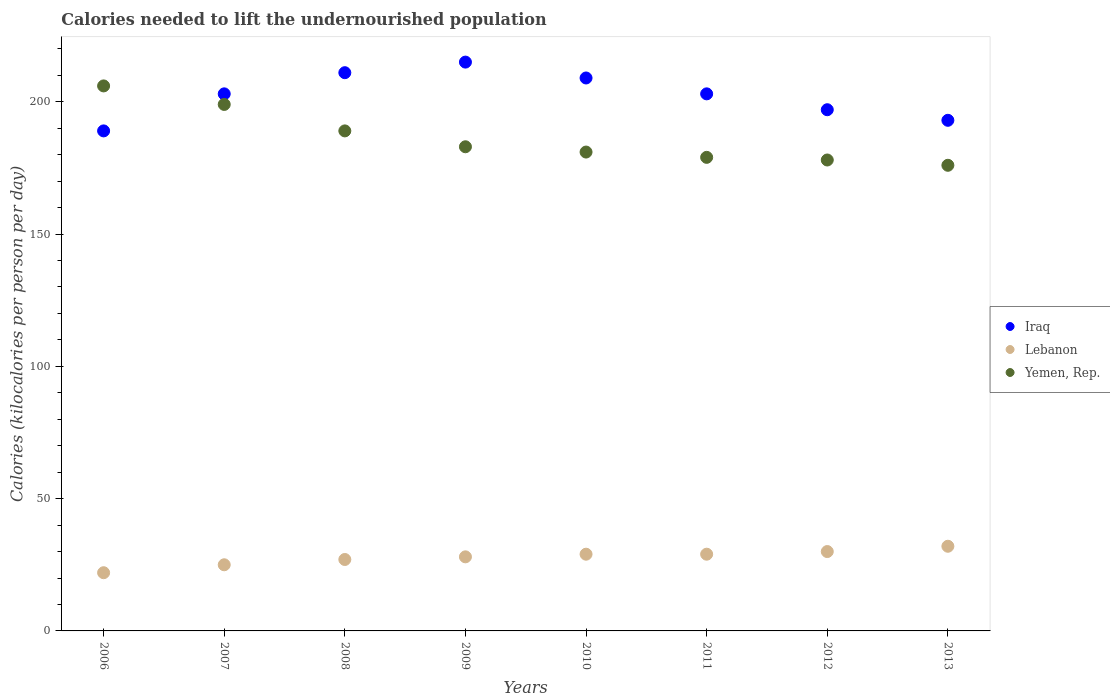How many different coloured dotlines are there?
Keep it short and to the point. 3. Is the number of dotlines equal to the number of legend labels?
Make the answer very short. Yes. What is the total calories needed to lift the undernourished population in Yemen, Rep. in 2013?
Your answer should be compact. 176. Across all years, what is the maximum total calories needed to lift the undernourished population in Lebanon?
Your answer should be very brief. 32. Across all years, what is the minimum total calories needed to lift the undernourished population in Iraq?
Your response must be concise. 189. What is the total total calories needed to lift the undernourished population in Iraq in the graph?
Provide a succinct answer. 1620. What is the difference between the total calories needed to lift the undernourished population in Iraq in 2008 and that in 2011?
Keep it short and to the point. 8. What is the difference between the total calories needed to lift the undernourished population in Yemen, Rep. in 2011 and the total calories needed to lift the undernourished population in Lebanon in 2012?
Your answer should be very brief. 149. What is the average total calories needed to lift the undernourished population in Iraq per year?
Ensure brevity in your answer.  202.5. In the year 2006, what is the difference between the total calories needed to lift the undernourished population in Lebanon and total calories needed to lift the undernourished population in Iraq?
Keep it short and to the point. -167. What is the ratio of the total calories needed to lift the undernourished population in Yemen, Rep. in 2007 to that in 2013?
Your answer should be very brief. 1.13. What is the difference between the highest and the second highest total calories needed to lift the undernourished population in Lebanon?
Make the answer very short. 2. What is the difference between the highest and the lowest total calories needed to lift the undernourished population in Iraq?
Keep it short and to the point. 26. In how many years, is the total calories needed to lift the undernourished population in Iraq greater than the average total calories needed to lift the undernourished population in Iraq taken over all years?
Offer a terse response. 5. Is it the case that in every year, the sum of the total calories needed to lift the undernourished population in Iraq and total calories needed to lift the undernourished population in Lebanon  is greater than the total calories needed to lift the undernourished population in Yemen, Rep.?
Make the answer very short. Yes. Does the total calories needed to lift the undernourished population in Yemen, Rep. monotonically increase over the years?
Give a very brief answer. No. How many years are there in the graph?
Your answer should be compact. 8. What is the difference between two consecutive major ticks on the Y-axis?
Keep it short and to the point. 50. Are the values on the major ticks of Y-axis written in scientific E-notation?
Offer a very short reply. No. Does the graph contain any zero values?
Your answer should be compact. No. Where does the legend appear in the graph?
Provide a succinct answer. Center right. How many legend labels are there?
Offer a very short reply. 3. What is the title of the graph?
Make the answer very short. Calories needed to lift the undernourished population. Does "Netherlands" appear as one of the legend labels in the graph?
Ensure brevity in your answer.  No. What is the label or title of the X-axis?
Ensure brevity in your answer.  Years. What is the label or title of the Y-axis?
Provide a short and direct response. Calories (kilocalories per person per day). What is the Calories (kilocalories per person per day) of Iraq in 2006?
Make the answer very short. 189. What is the Calories (kilocalories per person per day) in Lebanon in 2006?
Provide a short and direct response. 22. What is the Calories (kilocalories per person per day) of Yemen, Rep. in 2006?
Make the answer very short. 206. What is the Calories (kilocalories per person per day) in Iraq in 2007?
Offer a very short reply. 203. What is the Calories (kilocalories per person per day) in Lebanon in 2007?
Provide a short and direct response. 25. What is the Calories (kilocalories per person per day) in Yemen, Rep. in 2007?
Ensure brevity in your answer.  199. What is the Calories (kilocalories per person per day) of Iraq in 2008?
Ensure brevity in your answer.  211. What is the Calories (kilocalories per person per day) of Lebanon in 2008?
Offer a terse response. 27. What is the Calories (kilocalories per person per day) of Yemen, Rep. in 2008?
Your answer should be compact. 189. What is the Calories (kilocalories per person per day) in Iraq in 2009?
Give a very brief answer. 215. What is the Calories (kilocalories per person per day) of Lebanon in 2009?
Your answer should be compact. 28. What is the Calories (kilocalories per person per day) in Yemen, Rep. in 2009?
Your answer should be compact. 183. What is the Calories (kilocalories per person per day) of Iraq in 2010?
Provide a succinct answer. 209. What is the Calories (kilocalories per person per day) in Yemen, Rep. in 2010?
Make the answer very short. 181. What is the Calories (kilocalories per person per day) of Iraq in 2011?
Provide a short and direct response. 203. What is the Calories (kilocalories per person per day) of Lebanon in 2011?
Your answer should be very brief. 29. What is the Calories (kilocalories per person per day) in Yemen, Rep. in 2011?
Your response must be concise. 179. What is the Calories (kilocalories per person per day) of Iraq in 2012?
Provide a succinct answer. 197. What is the Calories (kilocalories per person per day) in Lebanon in 2012?
Your response must be concise. 30. What is the Calories (kilocalories per person per day) of Yemen, Rep. in 2012?
Provide a short and direct response. 178. What is the Calories (kilocalories per person per day) of Iraq in 2013?
Keep it short and to the point. 193. What is the Calories (kilocalories per person per day) of Yemen, Rep. in 2013?
Give a very brief answer. 176. Across all years, what is the maximum Calories (kilocalories per person per day) in Iraq?
Your response must be concise. 215. Across all years, what is the maximum Calories (kilocalories per person per day) in Yemen, Rep.?
Your answer should be compact. 206. Across all years, what is the minimum Calories (kilocalories per person per day) in Iraq?
Give a very brief answer. 189. Across all years, what is the minimum Calories (kilocalories per person per day) of Yemen, Rep.?
Ensure brevity in your answer.  176. What is the total Calories (kilocalories per person per day) of Iraq in the graph?
Keep it short and to the point. 1620. What is the total Calories (kilocalories per person per day) in Lebanon in the graph?
Make the answer very short. 222. What is the total Calories (kilocalories per person per day) of Yemen, Rep. in the graph?
Give a very brief answer. 1491. What is the difference between the Calories (kilocalories per person per day) of Iraq in 2006 and that in 2007?
Your answer should be very brief. -14. What is the difference between the Calories (kilocalories per person per day) of Iraq in 2006 and that in 2008?
Ensure brevity in your answer.  -22. What is the difference between the Calories (kilocalories per person per day) in Lebanon in 2006 and that in 2008?
Ensure brevity in your answer.  -5. What is the difference between the Calories (kilocalories per person per day) in Iraq in 2006 and that in 2009?
Ensure brevity in your answer.  -26. What is the difference between the Calories (kilocalories per person per day) of Lebanon in 2006 and that in 2009?
Provide a short and direct response. -6. What is the difference between the Calories (kilocalories per person per day) of Iraq in 2006 and that in 2010?
Keep it short and to the point. -20. What is the difference between the Calories (kilocalories per person per day) in Yemen, Rep. in 2006 and that in 2010?
Offer a terse response. 25. What is the difference between the Calories (kilocalories per person per day) of Iraq in 2006 and that in 2011?
Provide a short and direct response. -14. What is the difference between the Calories (kilocalories per person per day) of Lebanon in 2006 and that in 2011?
Your response must be concise. -7. What is the difference between the Calories (kilocalories per person per day) of Yemen, Rep. in 2006 and that in 2011?
Offer a very short reply. 27. What is the difference between the Calories (kilocalories per person per day) in Iraq in 2006 and that in 2012?
Ensure brevity in your answer.  -8. What is the difference between the Calories (kilocalories per person per day) in Lebanon in 2006 and that in 2012?
Your response must be concise. -8. What is the difference between the Calories (kilocalories per person per day) in Yemen, Rep. in 2006 and that in 2012?
Your answer should be compact. 28. What is the difference between the Calories (kilocalories per person per day) in Lebanon in 2006 and that in 2013?
Your response must be concise. -10. What is the difference between the Calories (kilocalories per person per day) of Yemen, Rep. in 2006 and that in 2013?
Your answer should be compact. 30. What is the difference between the Calories (kilocalories per person per day) of Iraq in 2007 and that in 2010?
Your answer should be compact. -6. What is the difference between the Calories (kilocalories per person per day) of Lebanon in 2007 and that in 2010?
Your response must be concise. -4. What is the difference between the Calories (kilocalories per person per day) in Iraq in 2007 and that in 2012?
Your answer should be compact. 6. What is the difference between the Calories (kilocalories per person per day) in Yemen, Rep. in 2007 and that in 2012?
Your response must be concise. 21. What is the difference between the Calories (kilocalories per person per day) of Iraq in 2008 and that in 2009?
Keep it short and to the point. -4. What is the difference between the Calories (kilocalories per person per day) in Lebanon in 2008 and that in 2009?
Provide a succinct answer. -1. What is the difference between the Calories (kilocalories per person per day) of Yemen, Rep. in 2008 and that in 2009?
Provide a short and direct response. 6. What is the difference between the Calories (kilocalories per person per day) of Yemen, Rep. in 2008 and that in 2011?
Give a very brief answer. 10. What is the difference between the Calories (kilocalories per person per day) of Iraq in 2008 and that in 2012?
Offer a terse response. 14. What is the difference between the Calories (kilocalories per person per day) of Lebanon in 2008 and that in 2012?
Provide a succinct answer. -3. What is the difference between the Calories (kilocalories per person per day) of Iraq in 2008 and that in 2013?
Provide a succinct answer. 18. What is the difference between the Calories (kilocalories per person per day) in Lebanon in 2009 and that in 2010?
Make the answer very short. -1. What is the difference between the Calories (kilocalories per person per day) of Yemen, Rep. in 2009 and that in 2010?
Offer a very short reply. 2. What is the difference between the Calories (kilocalories per person per day) in Iraq in 2009 and that in 2011?
Make the answer very short. 12. What is the difference between the Calories (kilocalories per person per day) in Lebanon in 2009 and that in 2011?
Provide a succinct answer. -1. What is the difference between the Calories (kilocalories per person per day) in Yemen, Rep. in 2009 and that in 2011?
Give a very brief answer. 4. What is the difference between the Calories (kilocalories per person per day) in Yemen, Rep. in 2009 and that in 2012?
Provide a succinct answer. 5. What is the difference between the Calories (kilocalories per person per day) in Lebanon in 2009 and that in 2013?
Your response must be concise. -4. What is the difference between the Calories (kilocalories per person per day) of Yemen, Rep. in 2009 and that in 2013?
Provide a succinct answer. 7. What is the difference between the Calories (kilocalories per person per day) of Lebanon in 2010 and that in 2011?
Ensure brevity in your answer.  0. What is the difference between the Calories (kilocalories per person per day) in Iraq in 2010 and that in 2012?
Your response must be concise. 12. What is the difference between the Calories (kilocalories per person per day) of Yemen, Rep. in 2010 and that in 2012?
Your response must be concise. 3. What is the difference between the Calories (kilocalories per person per day) of Iraq in 2010 and that in 2013?
Offer a terse response. 16. What is the difference between the Calories (kilocalories per person per day) in Lebanon in 2010 and that in 2013?
Keep it short and to the point. -3. What is the difference between the Calories (kilocalories per person per day) of Yemen, Rep. in 2010 and that in 2013?
Provide a succinct answer. 5. What is the difference between the Calories (kilocalories per person per day) of Iraq in 2011 and that in 2013?
Provide a short and direct response. 10. What is the difference between the Calories (kilocalories per person per day) in Yemen, Rep. in 2011 and that in 2013?
Keep it short and to the point. 3. What is the difference between the Calories (kilocalories per person per day) of Iraq in 2012 and that in 2013?
Give a very brief answer. 4. What is the difference between the Calories (kilocalories per person per day) in Iraq in 2006 and the Calories (kilocalories per person per day) in Lebanon in 2007?
Give a very brief answer. 164. What is the difference between the Calories (kilocalories per person per day) of Iraq in 2006 and the Calories (kilocalories per person per day) of Yemen, Rep. in 2007?
Give a very brief answer. -10. What is the difference between the Calories (kilocalories per person per day) of Lebanon in 2006 and the Calories (kilocalories per person per day) of Yemen, Rep. in 2007?
Give a very brief answer. -177. What is the difference between the Calories (kilocalories per person per day) of Iraq in 2006 and the Calories (kilocalories per person per day) of Lebanon in 2008?
Offer a very short reply. 162. What is the difference between the Calories (kilocalories per person per day) in Lebanon in 2006 and the Calories (kilocalories per person per day) in Yemen, Rep. in 2008?
Your answer should be very brief. -167. What is the difference between the Calories (kilocalories per person per day) in Iraq in 2006 and the Calories (kilocalories per person per day) in Lebanon in 2009?
Give a very brief answer. 161. What is the difference between the Calories (kilocalories per person per day) in Lebanon in 2006 and the Calories (kilocalories per person per day) in Yemen, Rep. in 2009?
Offer a terse response. -161. What is the difference between the Calories (kilocalories per person per day) of Iraq in 2006 and the Calories (kilocalories per person per day) of Lebanon in 2010?
Provide a short and direct response. 160. What is the difference between the Calories (kilocalories per person per day) of Lebanon in 2006 and the Calories (kilocalories per person per day) of Yemen, Rep. in 2010?
Offer a very short reply. -159. What is the difference between the Calories (kilocalories per person per day) of Iraq in 2006 and the Calories (kilocalories per person per day) of Lebanon in 2011?
Keep it short and to the point. 160. What is the difference between the Calories (kilocalories per person per day) of Iraq in 2006 and the Calories (kilocalories per person per day) of Yemen, Rep. in 2011?
Your answer should be compact. 10. What is the difference between the Calories (kilocalories per person per day) of Lebanon in 2006 and the Calories (kilocalories per person per day) of Yemen, Rep. in 2011?
Give a very brief answer. -157. What is the difference between the Calories (kilocalories per person per day) of Iraq in 2006 and the Calories (kilocalories per person per day) of Lebanon in 2012?
Your response must be concise. 159. What is the difference between the Calories (kilocalories per person per day) of Lebanon in 2006 and the Calories (kilocalories per person per day) of Yemen, Rep. in 2012?
Offer a terse response. -156. What is the difference between the Calories (kilocalories per person per day) of Iraq in 2006 and the Calories (kilocalories per person per day) of Lebanon in 2013?
Keep it short and to the point. 157. What is the difference between the Calories (kilocalories per person per day) in Lebanon in 2006 and the Calories (kilocalories per person per day) in Yemen, Rep. in 2013?
Ensure brevity in your answer.  -154. What is the difference between the Calories (kilocalories per person per day) of Iraq in 2007 and the Calories (kilocalories per person per day) of Lebanon in 2008?
Provide a short and direct response. 176. What is the difference between the Calories (kilocalories per person per day) in Lebanon in 2007 and the Calories (kilocalories per person per day) in Yemen, Rep. in 2008?
Provide a short and direct response. -164. What is the difference between the Calories (kilocalories per person per day) of Iraq in 2007 and the Calories (kilocalories per person per day) of Lebanon in 2009?
Your response must be concise. 175. What is the difference between the Calories (kilocalories per person per day) in Lebanon in 2007 and the Calories (kilocalories per person per day) in Yemen, Rep. in 2009?
Provide a succinct answer. -158. What is the difference between the Calories (kilocalories per person per day) of Iraq in 2007 and the Calories (kilocalories per person per day) of Lebanon in 2010?
Make the answer very short. 174. What is the difference between the Calories (kilocalories per person per day) in Lebanon in 2007 and the Calories (kilocalories per person per day) in Yemen, Rep. in 2010?
Keep it short and to the point. -156. What is the difference between the Calories (kilocalories per person per day) of Iraq in 2007 and the Calories (kilocalories per person per day) of Lebanon in 2011?
Keep it short and to the point. 174. What is the difference between the Calories (kilocalories per person per day) in Lebanon in 2007 and the Calories (kilocalories per person per day) in Yemen, Rep. in 2011?
Make the answer very short. -154. What is the difference between the Calories (kilocalories per person per day) in Iraq in 2007 and the Calories (kilocalories per person per day) in Lebanon in 2012?
Give a very brief answer. 173. What is the difference between the Calories (kilocalories per person per day) in Iraq in 2007 and the Calories (kilocalories per person per day) in Yemen, Rep. in 2012?
Make the answer very short. 25. What is the difference between the Calories (kilocalories per person per day) in Lebanon in 2007 and the Calories (kilocalories per person per day) in Yemen, Rep. in 2012?
Keep it short and to the point. -153. What is the difference between the Calories (kilocalories per person per day) of Iraq in 2007 and the Calories (kilocalories per person per day) of Lebanon in 2013?
Your answer should be compact. 171. What is the difference between the Calories (kilocalories per person per day) in Iraq in 2007 and the Calories (kilocalories per person per day) in Yemen, Rep. in 2013?
Provide a succinct answer. 27. What is the difference between the Calories (kilocalories per person per day) of Lebanon in 2007 and the Calories (kilocalories per person per day) of Yemen, Rep. in 2013?
Give a very brief answer. -151. What is the difference between the Calories (kilocalories per person per day) in Iraq in 2008 and the Calories (kilocalories per person per day) in Lebanon in 2009?
Offer a terse response. 183. What is the difference between the Calories (kilocalories per person per day) of Lebanon in 2008 and the Calories (kilocalories per person per day) of Yemen, Rep. in 2009?
Provide a short and direct response. -156. What is the difference between the Calories (kilocalories per person per day) in Iraq in 2008 and the Calories (kilocalories per person per day) in Lebanon in 2010?
Make the answer very short. 182. What is the difference between the Calories (kilocalories per person per day) in Iraq in 2008 and the Calories (kilocalories per person per day) in Yemen, Rep. in 2010?
Your answer should be compact. 30. What is the difference between the Calories (kilocalories per person per day) in Lebanon in 2008 and the Calories (kilocalories per person per day) in Yemen, Rep. in 2010?
Provide a succinct answer. -154. What is the difference between the Calories (kilocalories per person per day) of Iraq in 2008 and the Calories (kilocalories per person per day) of Lebanon in 2011?
Offer a terse response. 182. What is the difference between the Calories (kilocalories per person per day) of Lebanon in 2008 and the Calories (kilocalories per person per day) of Yemen, Rep. in 2011?
Your response must be concise. -152. What is the difference between the Calories (kilocalories per person per day) of Iraq in 2008 and the Calories (kilocalories per person per day) of Lebanon in 2012?
Provide a short and direct response. 181. What is the difference between the Calories (kilocalories per person per day) of Iraq in 2008 and the Calories (kilocalories per person per day) of Yemen, Rep. in 2012?
Offer a very short reply. 33. What is the difference between the Calories (kilocalories per person per day) in Lebanon in 2008 and the Calories (kilocalories per person per day) in Yemen, Rep. in 2012?
Your response must be concise. -151. What is the difference between the Calories (kilocalories per person per day) in Iraq in 2008 and the Calories (kilocalories per person per day) in Lebanon in 2013?
Provide a short and direct response. 179. What is the difference between the Calories (kilocalories per person per day) of Iraq in 2008 and the Calories (kilocalories per person per day) of Yemen, Rep. in 2013?
Give a very brief answer. 35. What is the difference between the Calories (kilocalories per person per day) of Lebanon in 2008 and the Calories (kilocalories per person per day) of Yemen, Rep. in 2013?
Ensure brevity in your answer.  -149. What is the difference between the Calories (kilocalories per person per day) in Iraq in 2009 and the Calories (kilocalories per person per day) in Lebanon in 2010?
Provide a succinct answer. 186. What is the difference between the Calories (kilocalories per person per day) in Iraq in 2009 and the Calories (kilocalories per person per day) in Yemen, Rep. in 2010?
Provide a succinct answer. 34. What is the difference between the Calories (kilocalories per person per day) of Lebanon in 2009 and the Calories (kilocalories per person per day) of Yemen, Rep. in 2010?
Your answer should be very brief. -153. What is the difference between the Calories (kilocalories per person per day) in Iraq in 2009 and the Calories (kilocalories per person per day) in Lebanon in 2011?
Provide a succinct answer. 186. What is the difference between the Calories (kilocalories per person per day) in Lebanon in 2009 and the Calories (kilocalories per person per day) in Yemen, Rep. in 2011?
Provide a succinct answer. -151. What is the difference between the Calories (kilocalories per person per day) of Iraq in 2009 and the Calories (kilocalories per person per day) of Lebanon in 2012?
Offer a terse response. 185. What is the difference between the Calories (kilocalories per person per day) in Lebanon in 2009 and the Calories (kilocalories per person per day) in Yemen, Rep. in 2012?
Provide a succinct answer. -150. What is the difference between the Calories (kilocalories per person per day) in Iraq in 2009 and the Calories (kilocalories per person per day) in Lebanon in 2013?
Make the answer very short. 183. What is the difference between the Calories (kilocalories per person per day) of Lebanon in 2009 and the Calories (kilocalories per person per day) of Yemen, Rep. in 2013?
Ensure brevity in your answer.  -148. What is the difference between the Calories (kilocalories per person per day) in Iraq in 2010 and the Calories (kilocalories per person per day) in Lebanon in 2011?
Keep it short and to the point. 180. What is the difference between the Calories (kilocalories per person per day) in Iraq in 2010 and the Calories (kilocalories per person per day) in Yemen, Rep. in 2011?
Your response must be concise. 30. What is the difference between the Calories (kilocalories per person per day) of Lebanon in 2010 and the Calories (kilocalories per person per day) of Yemen, Rep. in 2011?
Your answer should be compact. -150. What is the difference between the Calories (kilocalories per person per day) in Iraq in 2010 and the Calories (kilocalories per person per day) in Lebanon in 2012?
Give a very brief answer. 179. What is the difference between the Calories (kilocalories per person per day) of Iraq in 2010 and the Calories (kilocalories per person per day) of Yemen, Rep. in 2012?
Offer a terse response. 31. What is the difference between the Calories (kilocalories per person per day) in Lebanon in 2010 and the Calories (kilocalories per person per day) in Yemen, Rep. in 2012?
Provide a short and direct response. -149. What is the difference between the Calories (kilocalories per person per day) of Iraq in 2010 and the Calories (kilocalories per person per day) of Lebanon in 2013?
Your response must be concise. 177. What is the difference between the Calories (kilocalories per person per day) in Iraq in 2010 and the Calories (kilocalories per person per day) in Yemen, Rep. in 2013?
Give a very brief answer. 33. What is the difference between the Calories (kilocalories per person per day) in Lebanon in 2010 and the Calories (kilocalories per person per day) in Yemen, Rep. in 2013?
Your answer should be very brief. -147. What is the difference between the Calories (kilocalories per person per day) of Iraq in 2011 and the Calories (kilocalories per person per day) of Lebanon in 2012?
Offer a terse response. 173. What is the difference between the Calories (kilocalories per person per day) in Iraq in 2011 and the Calories (kilocalories per person per day) in Yemen, Rep. in 2012?
Provide a succinct answer. 25. What is the difference between the Calories (kilocalories per person per day) in Lebanon in 2011 and the Calories (kilocalories per person per day) in Yemen, Rep. in 2012?
Your answer should be very brief. -149. What is the difference between the Calories (kilocalories per person per day) of Iraq in 2011 and the Calories (kilocalories per person per day) of Lebanon in 2013?
Provide a short and direct response. 171. What is the difference between the Calories (kilocalories per person per day) in Iraq in 2011 and the Calories (kilocalories per person per day) in Yemen, Rep. in 2013?
Give a very brief answer. 27. What is the difference between the Calories (kilocalories per person per day) in Lebanon in 2011 and the Calories (kilocalories per person per day) in Yemen, Rep. in 2013?
Give a very brief answer. -147. What is the difference between the Calories (kilocalories per person per day) of Iraq in 2012 and the Calories (kilocalories per person per day) of Lebanon in 2013?
Keep it short and to the point. 165. What is the difference between the Calories (kilocalories per person per day) of Lebanon in 2012 and the Calories (kilocalories per person per day) of Yemen, Rep. in 2013?
Make the answer very short. -146. What is the average Calories (kilocalories per person per day) in Iraq per year?
Provide a succinct answer. 202.5. What is the average Calories (kilocalories per person per day) of Lebanon per year?
Provide a succinct answer. 27.75. What is the average Calories (kilocalories per person per day) of Yemen, Rep. per year?
Give a very brief answer. 186.38. In the year 2006, what is the difference between the Calories (kilocalories per person per day) of Iraq and Calories (kilocalories per person per day) of Lebanon?
Offer a very short reply. 167. In the year 2006, what is the difference between the Calories (kilocalories per person per day) in Iraq and Calories (kilocalories per person per day) in Yemen, Rep.?
Make the answer very short. -17. In the year 2006, what is the difference between the Calories (kilocalories per person per day) in Lebanon and Calories (kilocalories per person per day) in Yemen, Rep.?
Give a very brief answer. -184. In the year 2007, what is the difference between the Calories (kilocalories per person per day) in Iraq and Calories (kilocalories per person per day) in Lebanon?
Your response must be concise. 178. In the year 2007, what is the difference between the Calories (kilocalories per person per day) of Lebanon and Calories (kilocalories per person per day) of Yemen, Rep.?
Provide a short and direct response. -174. In the year 2008, what is the difference between the Calories (kilocalories per person per day) in Iraq and Calories (kilocalories per person per day) in Lebanon?
Offer a very short reply. 184. In the year 2008, what is the difference between the Calories (kilocalories per person per day) in Lebanon and Calories (kilocalories per person per day) in Yemen, Rep.?
Give a very brief answer. -162. In the year 2009, what is the difference between the Calories (kilocalories per person per day) in Iraq and Calories (kilocalories per person per day) in Lebanon?
Keep it short and to the point. 187. In the year 2009, what is the difference between the Calories (kilocalories per person per day) of Lebanon and Calories (kilocalories per person per day) of Yemen, Rep.?
Give a very brief answer. -155. In the year 2010, what is the difference between the Calories (kilocalories per person per day) of Iraq and Calories (kilocalories per person per day) of Lebanon?
Give a very brief answer. 180. In the year 2010, what is the difference between the Calories (kilocalories per person per day) in Lebanon and Calories (kilocalories per person per day) in Yemen, Rep.?
Offer a very short reply. -152. In the year 2011, what is the difference between the Calories (kilocalories per person per day) in Iraq and Calories (kilocalories per person per day) in Lebanon?
Ensure brevity in your answer.  174. In the year 2011, what is the difference between the Calories (kilocalories per person per day) in Iraq and Calories (kilocalories per person per day) in Yemen, Rep.?
Keep it short and to the point. 24. In the year 2011, what is the difference between the Calories (kilocalories per person per day) in Lebanon and Calories (kilocalories per person per day) in Yemen, Rep.?
Make the answer very short. -150. In the year 2012, what is the difference between the Calories (kilocalories per person per day) of Iraq and Calories (kilocalories per person per day) of Lebanon?
Your answer should be compact. 167. In the year 2012, what is the difference between the Calories (kilocalories per person per day) in Iraq and Calories (kilocalories per person per day) in Yemen, Rep.?
Offer a terse response. 19. In the year 2012, what is the difference between the Calories (kilocalories per person per day) of Lebanon and Calories (kilocalories per person per day) of Yemen, Rep.?
Your answer should be very brief. -148. In the year 2013, what is the difference between the Calories (kilocalories per person per day) of Iraq and Calories (kilocalories per person per day) of Lebanon?
Offer a terse response. 161. In the year 2013, what is the difference between the Calories (kilocalories per person per day) in Lebanon and Calories (kilocalories per person per day) in Yemen, Rep.?
Make the answer very short. -144. What is the ratio of the Calories (kilocalories per person per day) in Iraq in 2006 to that in 2007?
Your answer should be very brief. 0.93. What is the ratio of the Calories (kilocalories per person per day) of Yemen, Rep. in 2006 to that in 2007?
Give a very brief answer. 1.04. What is the ratio of the Calories (kilocalories per person per day) in Iraq in 2006 to that in 2008?
Offer a terse response. 0.9. What is the ratio of the Calories (kilocalories per person per day) of Lebanon in 2006 to that in 2008?
Ensure brevity in your answer.  0.81. What is the ratio of the Calories (kilocalories per person per day) in Yemen, Rep. in 2006 to that in 2008?
Make the answer very short. 1.09. What is the ratio of the Calories (kilocalories per person per day) of Iraq in 2006 to that in 2009?
Make the answer very short. 0.88. What is the ratio of the Calories (kilocalories per person per day) of Lebanon in 2006 to that in 2009?
Your response must be concise. 0.79. What is the ratio of the Calories (kilocalories per person per day) of Yemen, Rep. in 2006 to that in 2009?
Give a very brief answer. 1.13. What is the ratio of the Calories (kilocalories per person per day) of Iraq in 2006 to that in 2010?
Your response must be concise. 0.9. What is the ratio of the Calories (kilocalories per person per day) in Lebanon in 2006 to that in 2010?
Provide a succinct answer. 0.76. What is the ratio of the Calories (kilocalories per person per day) in Yemen, Rep. in 2006 to that in 2010?
Provide a succinct answer. 1.14. What is the ratio of the Calories (kilocalories per person per day) of Iraq in 2006 to that in 2011?
Provide a short and direct response. 0.93. What is the ratio of the Calories (kilocalories per person per day) of Lebanon in 2006 to that in 2011?
Provide a succinct answer. 0.76. What is the ratio of the Calories (kilocalories per person per day) in Yemen, Rep. in 2006 to that in 2011?
Your answer should be compact. 1.15. What is the ratio of the Calories (kilocalories per person per day) of Iraq in 2006 to that in 2012?
Your response must be concise. 0.96. What is the ratio of the Calories (kilocalories per person per day) of Lebanon in 2006 to that in 2012?
Ensure brevity in your answer.  0.73. What is the ratio of the Calories (kilocalories per person per day) in Yemen, Rep. in 2006 to that in 2012?
Provide a succinct answer. 1.16. What is the ratio of the Calories (kilocalories per person per day) in Iraq in 2006 to that in 2013?
Provide a succinct answer. 0.98. What is the ratio of the Calories (kilocalories per person per day) in Lebanon in 2006 to that in 2013?
Your answer should be compact. 0.69. What is the ratio of the Calories (kilocalories per person per day) in Yemen, Rep. in 2006 to that in 2013?
Your response must be concise. 1.17. What is the ratio of the Calories (kilocalories per person per day) in Iraq in 2007 to that in 2008?
Offer a terse response. 0.96. What is the ratio of the Calories (kilocalories per person per day) in Lebanon in 2007 to that in 2008?
Keep it short and to the point. 0.93. What is the ratio of the Calories (kilocalories per person per day) of Yemen, Rep. in 2007 to that in 2008?
Provide a short and direct response. 1.05. What is the ratio of the Calories (kilocalories per person per day) in Iraq in 2007 to that in 2009?
Offer a very short reply. 0.94. What is the ratio of the Calories (kilocalories per person per day) of Lebanon in 2007 to that in 2009?
Provide a succinct answer. 0.89. What is the ratio of the Calories (kilocalories per person per day) of Yemen, Rep. in 2007 to that in 2009?
Provide a succinct answer. 1.09. What is the ratio of the Calories (kilocalories per person per day) of Iraq in 2007 to that in 2010?
Make the answer very short. 0.97. What is the ratio of the Calories (kilocalories per person per day) of Lebanon in 2007 to that in 2010?
Provide a short and direct response. 0.86. What is the ratio of the Calories (kilocalories per person per day) of Yemen, Rep. in 2007 to that in 2010?
Give a very brief answer. 1.1. What is the ratio of the Calories (kilocalories per person per day) of Iraq in 2007 to that in 2011?
Make the answer very short. 1. What is the ratio of the Calories (kilocalories per person per day) in Lebanon in 2007 to that in 2011?
Provide a short and direct response. 0.86. What is the ratio of the Calories (kilocalories per person per day) in Yemen, Rep. in 2007 to that in 2011?
Offer a terse response. 1.11. What is the ratio of the Calories (kilocalories per person per day) of Iraq in 2007 to that in 2012?
Offer a terse response. 1.03. What is the ratio of the Calories (kilocalories per person per day) of Lebanon in 2007 to that in 2012?
Your response must be concise. 0.83. What is the ratio of the Calories (kilocalories per person per day) of Yemen, Rep. in 2007 to that in 2012?
Your response must be concise. 1.12. What is the ratio of the Calories (kilocalories per person per day) in Iraq in 2007 to that in 2013?
Provide a succinct answer. 1.05. What is the ratio of the Calories (kilocalories per person per day) of Lebanon in 2007 to that in 2013?
Give a very brief answer. 0.78. What is the ratio of the Calories (kilocalories per person per day) in Yemen, Rep. in 2007 to that in 2013?
Provide a short and direct response. 1.13. What is the ratio of the Calories (kilocalories per person per day) in Iraq in 2008 to that in 2009?
Offer a very short reply. 0.98. What is the ratio of the Calories (kilocalories per person per day) in Yemen, Rep. in 2008 to that in 2009?
Your answer should be very brief. 1.03. What is the ratio of the Calories (kilocalories per person per day) in Iraq in 2008 to that in 2010?
Your answer should be compact. 1.01. What is the ratio of the Calories (kilocalories per person per day) of Lebanon in 2008 to that in 2010?
Ensure brevity in your answer.  0.93. What is the ratio of the Calories (kilocalories per person per day) of Yemen, Rep. in 2008 to that in 2010?
Your answer should be compact. 1.04. What is the ratio of the Calories (kilocalories per person per day) of Iraq in 2008 to that in 2011?
Give a very brief answer. 1.04. What is the ratio of the Calories (kilocalories per person per day) in Lebanon in 2008 to that in 2011?
Your response must be concise. 0.93. What is the ratio of the Calories (kilocalories per person per day) in Yemen, Rep. in 2008 to that in 2011?
Offer a very short reply. 1.06. What is the ratio of the Calories (kilocalories per person per day) of Iraq in 2008 to that in 2012?
Your answer should be compact. 1.07. What is the ratio of the Calories (kilocalories per person per day) in Lebanon in 2008 to that in 2012?
Provide a succinct answer. 0.9. What is the ratio of the Calories (kilocalories per person per day) in Yemen, Rep. in 2008 to that in 2012?
Ensure brevity in your answer.  1.06. What is the ratio of the Calories (kilocalories per person per day) of Iraq in 2008 to that in 2013?
Keep it short and to the point. 1.09. What is the ratio of the Calories (kilocalories per person per day) in Lebanon in 2008 to that in 2013?
Offer a terse response. 0.84. What is the ratio of the Calories (kilocalories per person per day) of Yemen, Rep. in 2008 to that in 2013?
Offer a terse response. 1.07. What is the ratio of the Calories (kilocalories per person per day) in Iraq in 2009 to that in 2010?
Provide a succinct answer. 1.03. What is the ratio of the Calories (kilocalories per person per day) of Lebanon in 2009 to that in 2010?
Your answer should be compact. 0.97. What is the ratio of the Calories (kilocalories per person per day) of Iraq in 2009 to that in 2011?
Give a very brief answer. 1.06. What is the ratio of the Calories (kilocalories per person per day) in Lebanon in 2009 to that in 2011?
Keep it short and to the point. 0.97. What is the ratio of the Calories (kilocalories per person per day) of Yemen, Rep. in 2009 to that in 2011?
Your response must be concise. 1.02. What is the ratio of the Calories (kilocalories per person per day) of Iraq in 2009 to that in 2012?
Keep it short and to the point. 1.09. What is the ratio of the Calories (kilocalories per person per day) of Lebanon in 2009 to that in 2012?
Make the answer very short. 0.93. What is the ratio of the Calories (kilocalories per person per day) in Yemen, Rep. in 2009 to that in 2012?
Give a very brief answer. 1.03. What is the ratio of the Calories (kilocalories per person per day) of Iraq in 2009 to that in 2013?
Provide a short and direct response. 1.11. What is the ratio of the Calories (kilocalories per person per day) in Yemen, Rep. in 2009 to that in 2013?
Make the answer very short. 1.04. What is the ratio of the Calories (kilocalories per person per day) of Iraq in 2010 to that in 2011?
Offer a very short reply. 1.03. What is the ratio of the Calories (kilocalories per person per day) in Yemen, Rep. in 2010 to that in 2011?
Make the answer very short. 1.01. What is the ratio of the Calories (kilocalories per person per day) of Iraq in 2010 to that in 2012?
Give a very brief answer. 1.06. What is the ratio of the Calories (kilocalories per person per day) of Lebanon in 2010 to that in 2012?
Give a very brief answer. 0.97. What is the ratio of the Calories (kilocalories per person per day) of Yemen, Rep. in 2010 to that in 2012?
Provide a short and direct response. 1.02. What is the ratio of the Calories (kilocalories per person per day) of Iraq in 2010 to that in 2013?
Your response must be concise. 1.08. What is the ratio of the Calories (kilocalories per person per day) in Lebanon in 2010 to that in 2013?
Keep it short and to the point. 0.91. What is the ratio of the Calories (kilocalories per person per day) in Yemen, Rep. in 2010 to that in 2013?
Your answer should be compact. 1.03. What is the ratio of the Calories (kilocalories per person per day) of Iraq in 2011 to that in 2012?
Keep it short and to the point. 1.03. What is the ratio of the Calories (kilocalories per person per day) in Lebanon in 2011 to that in 2012?
Give a very brief answer. 0.97. What is the ratio of the Calories (kilocalories per person per day) of Yemen, Rep. in 2011 to that in 2012?
Your answer should be very brief. 1.01. What is the ratio of the Calories (kilocalories per person per day) of Iraq in 2011 to that in 2013?
Your response must be concise. 1.05. What is the ratio of the Calories (kilocalories per person per day) in Lebanon in 2011 to that in 2013?
Your response must be concise. 0.91. What is the ratio of the Calories (kilocalories per person per day) of Iraq in 2012 to that in 2013?
Provide a succinct answer. 1.02. What is the ratio of the Calories (kilocalories per person per day) in Yemen, Rep. in 2012 to that in 2013?
Provide a succinct answer. 1.01. What is the difference between the highest and the second highest Calories (kilocalories per person per day) in Yemen, Rep.?
Make the answer very short. 7. What is the difference between the highest and the lowest Calories (kilocalories per person per day) of Iraq?
Give a very brief answer. 26. What is the difference between the highest and the lowest Calories (kilocalories per person per day) of Lebanon?
Your answer should be compact. 10. 